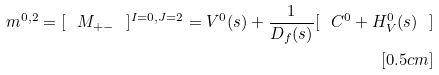Convert formula to latex. <formula><loc_0><loc_0><loc_500><loc_500>m ^ { 0 , 2 } = [ \ M _ { + - } \ ] ^ { I = 0 , J = 2 } = V ^ { 0 } ( s ) + \frac { 1 } { D _ { f } ( s ) } [ \ C ^ { 0 } + H ^ { 0 } _ { V } ( s ) \ ] \\ [ 0 . 5 c m ]</formula> 